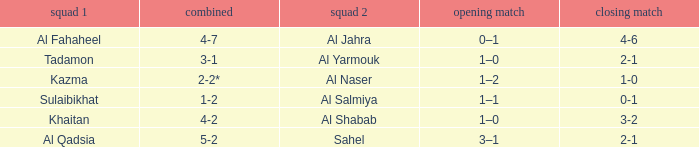What is the name of Team 2 with a 2nd leg of 4-6? Al Jahra. 